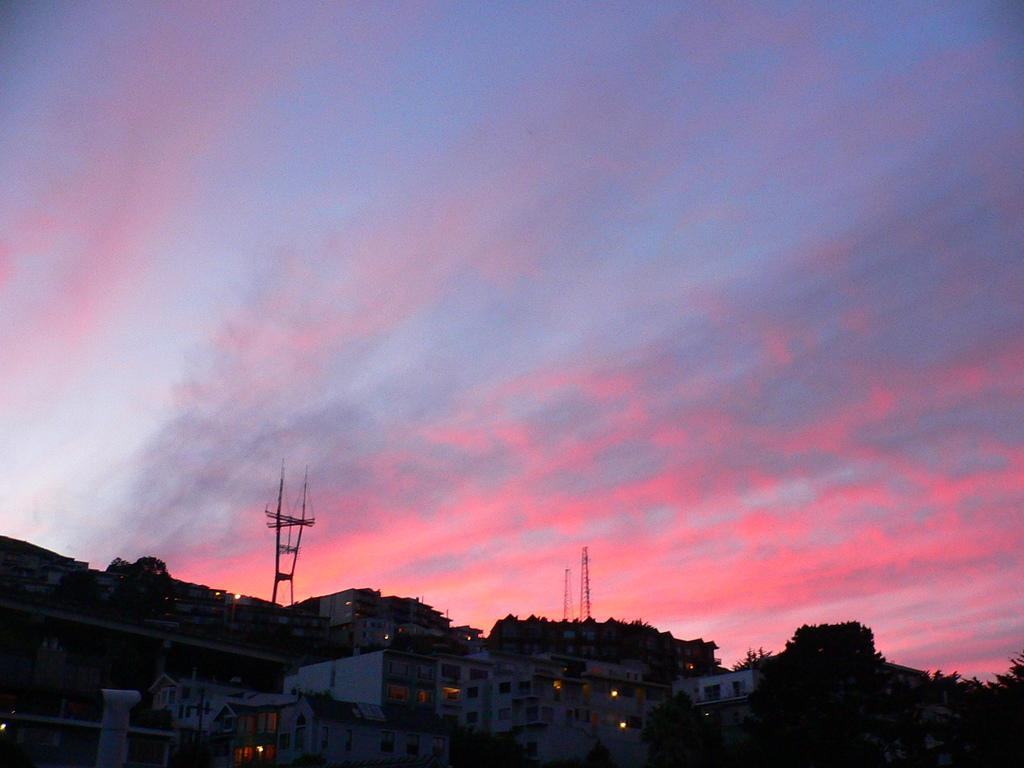What types of structures are located at the bottom of the image? There are buildings, trees, and towers at the bottom of the image. What can be seen in the sky in the image? The sky is visible at the top of the image, and clouds are present in the sky. What type of lunch is being served by the police in the image? There are no police or lunch present in the image; it features buildings, trees, towers, and a sky with clouds. What are the hands of the trees doing in the image? There are no hands present in the image, as trees do not have hands. 